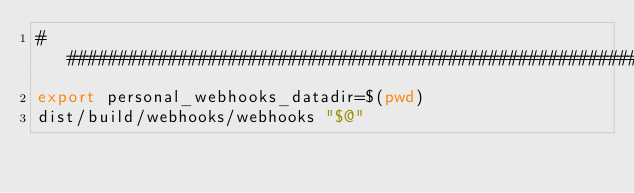Convert code to text. <code><loc_0><loc_0><loc_500><loc_500><_Bash_>################################################################################
export personal_webhooks_datadir=$(pwd)
dist/build/webhooks/webhooks "$@"
</code> 